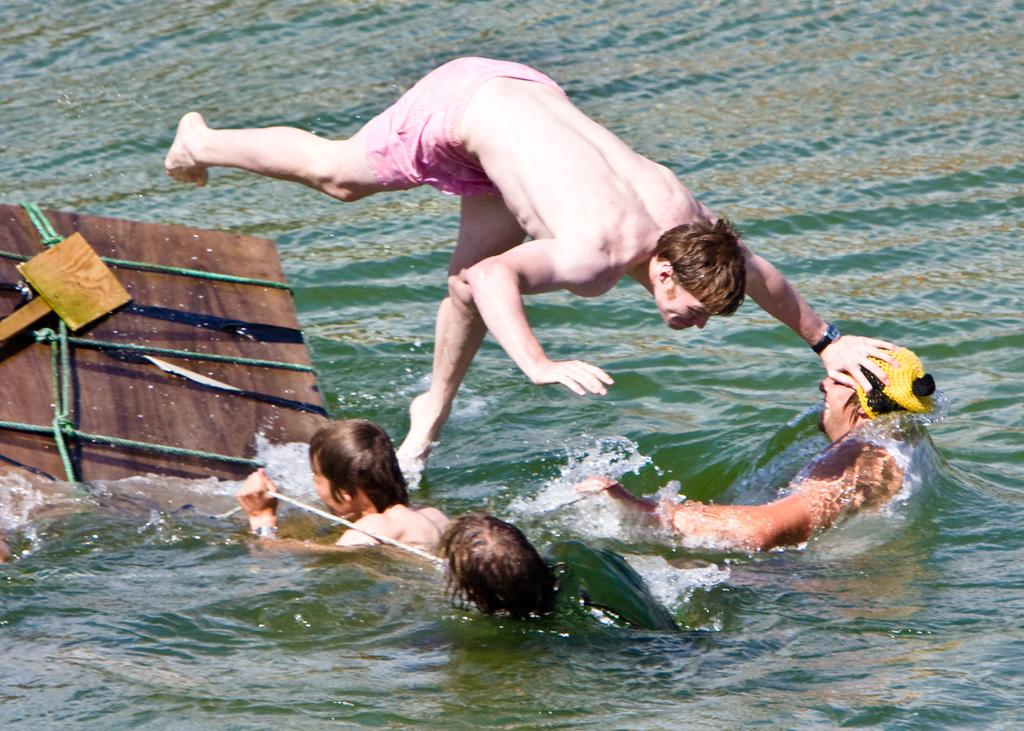What are the people in the image doing? The people in the image are in the water. What specific action is a man taking in the image? A man is jumping into the water. What can be seen on the left side of the image? There is an object on the left side of the image. How is the object on the left side of the image secured? The object is tied with ropes. What type of yarn is being used by the people in the water? There is no mention of yarn in the image. --- Facts: 1. There is a person in the image. 2. The person is wearing a hat. 3. The person is holding a book. 4. The book has a title on the cover. 5. The background of the image is a park. Absurd Topics: elephant, piano Conversation: Who or what is present in the image? There is a person in the image. What is the person wearing in the image? The person is wearing a hat. What is the person holding in the image? The person is holding a book. What can be seen on the book in the image? The book has a title on the cover. What can be seen in the background of the image? The background of the image is a park. Reasoning: Let's think step by step in order to ${produce the conversation}. We start by identifying the main subject of the image, which is the person. Next, we describe specific features of the person, such as the hat and the book they are holding. Then, we observe the actions of the person, noting that they are holding a book. Finally, we describe the background of the image, which is a park. Absurd Question/Answer: What type of elephant can be seen playing the piano in the image? There is no mention of an elephant or a piano in the image. 